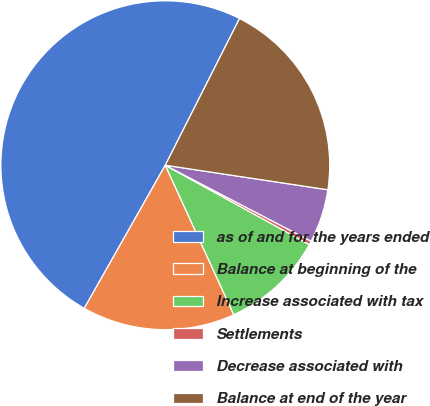Convert chart. <chart><loc_0><loc_0><loc_500><loc_500><pie_chart><fcel>as of and for the years ended<fcel>Balance at beginning of the<fcel>Increase associated with tax<fcel>Settlements<fcel>Decrease associated with<fcel>Balance at end of the year<nl><fcel>49.26%<fcel>15.04%<fcel>10.15%<fcel>0.37%<fcel>5.26%<fcel>19.93%<nl></chart> 